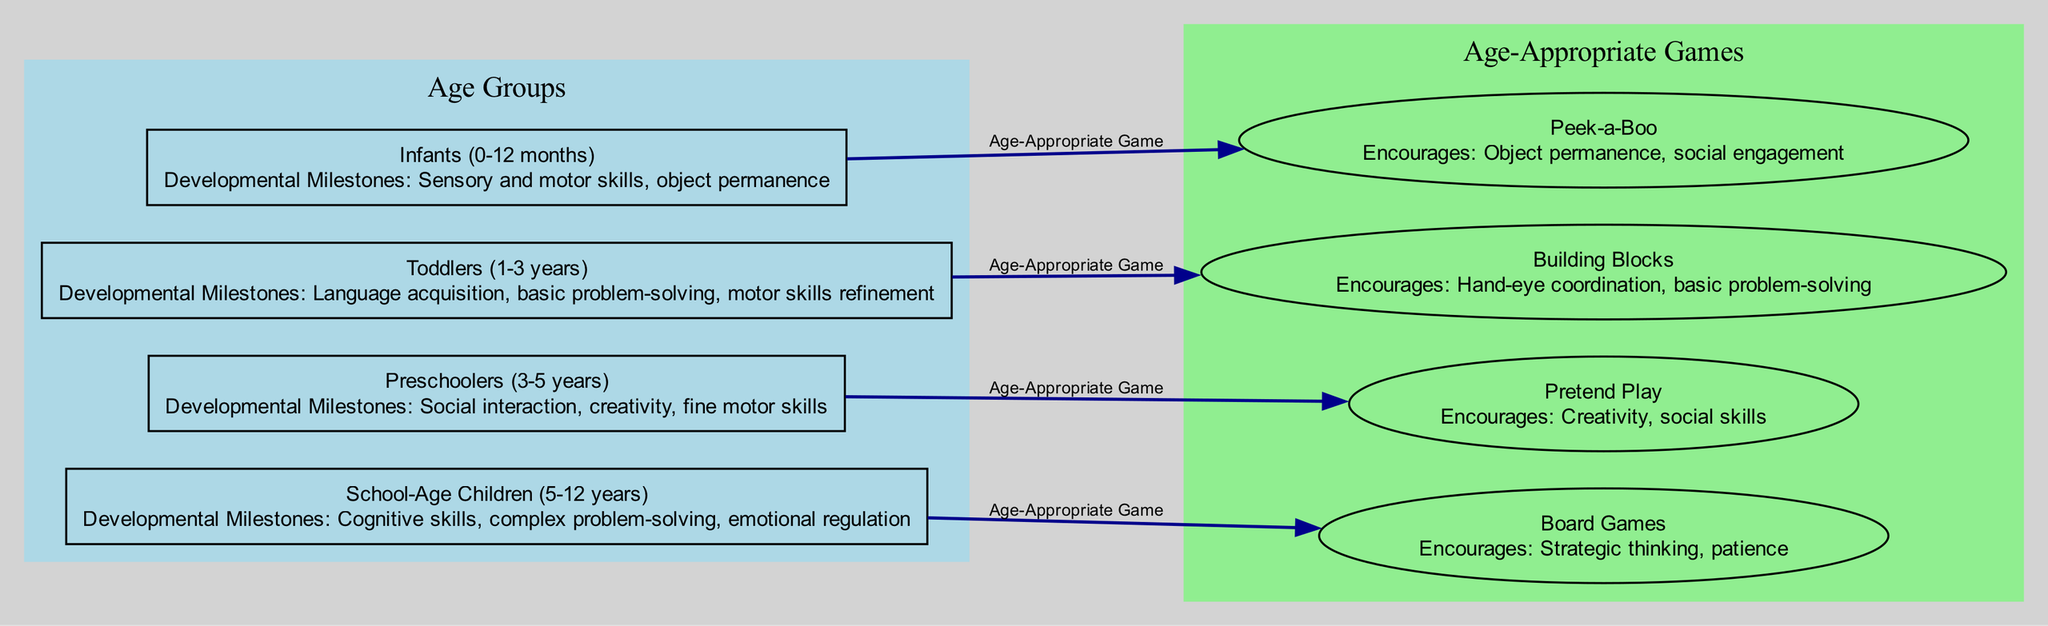What age group corresponds to the game "Peek-a-Boo"? The node for "Peek-a-Boo" shows that it is associated with infants, specifically indicated as the age group for Infants (0-12 months).
Answer: Infants (0-12 months) How many developmental milestones are listed for toddlers? The description for toddlers states they have three developmental milestones: language acquisition, basic problem-solving, and motor skills refinement.
Answer: Three Which game encourages social skills? The diagram indicates that "Pretend Play" encourages creativity and social skills, linking this game with preschoolers.
Answer: Pretend Play What is the relationship between school-age children and board games? The edge from "School-Age Children" to "Board Games" shows that board games are identified as an age-appropriate game for this group, thus indicating a direct relationship.
Answer: Age-Appropriate Game How many edges represent the connections from age groups to games? There are four edges connecting the age groups to their respective age-appropriate games; each edge represents one connection per age group.
Answer: Four What developmental milestone is associated with "Building Blocks"? The description for "Building Blocks" indicates that it encourages hand-eye coordination and basic problem-solving skills, which are essential milestones for toddlers.
Answer: Hand-eye coordination, basic problem-solving Is the game "Board Games" suitable for toddlers? The diagram does not show a connection from the toddlers' node to the board games node, indicating that board games are not age-appropriate for this age group.
Answer: No What are the age-specific games for preschoolers? The node for preschoolers points to "Pretend Play" as the age-appropriate game, indicating it is specifically designed for this age group.
Answer: Pretend Play 